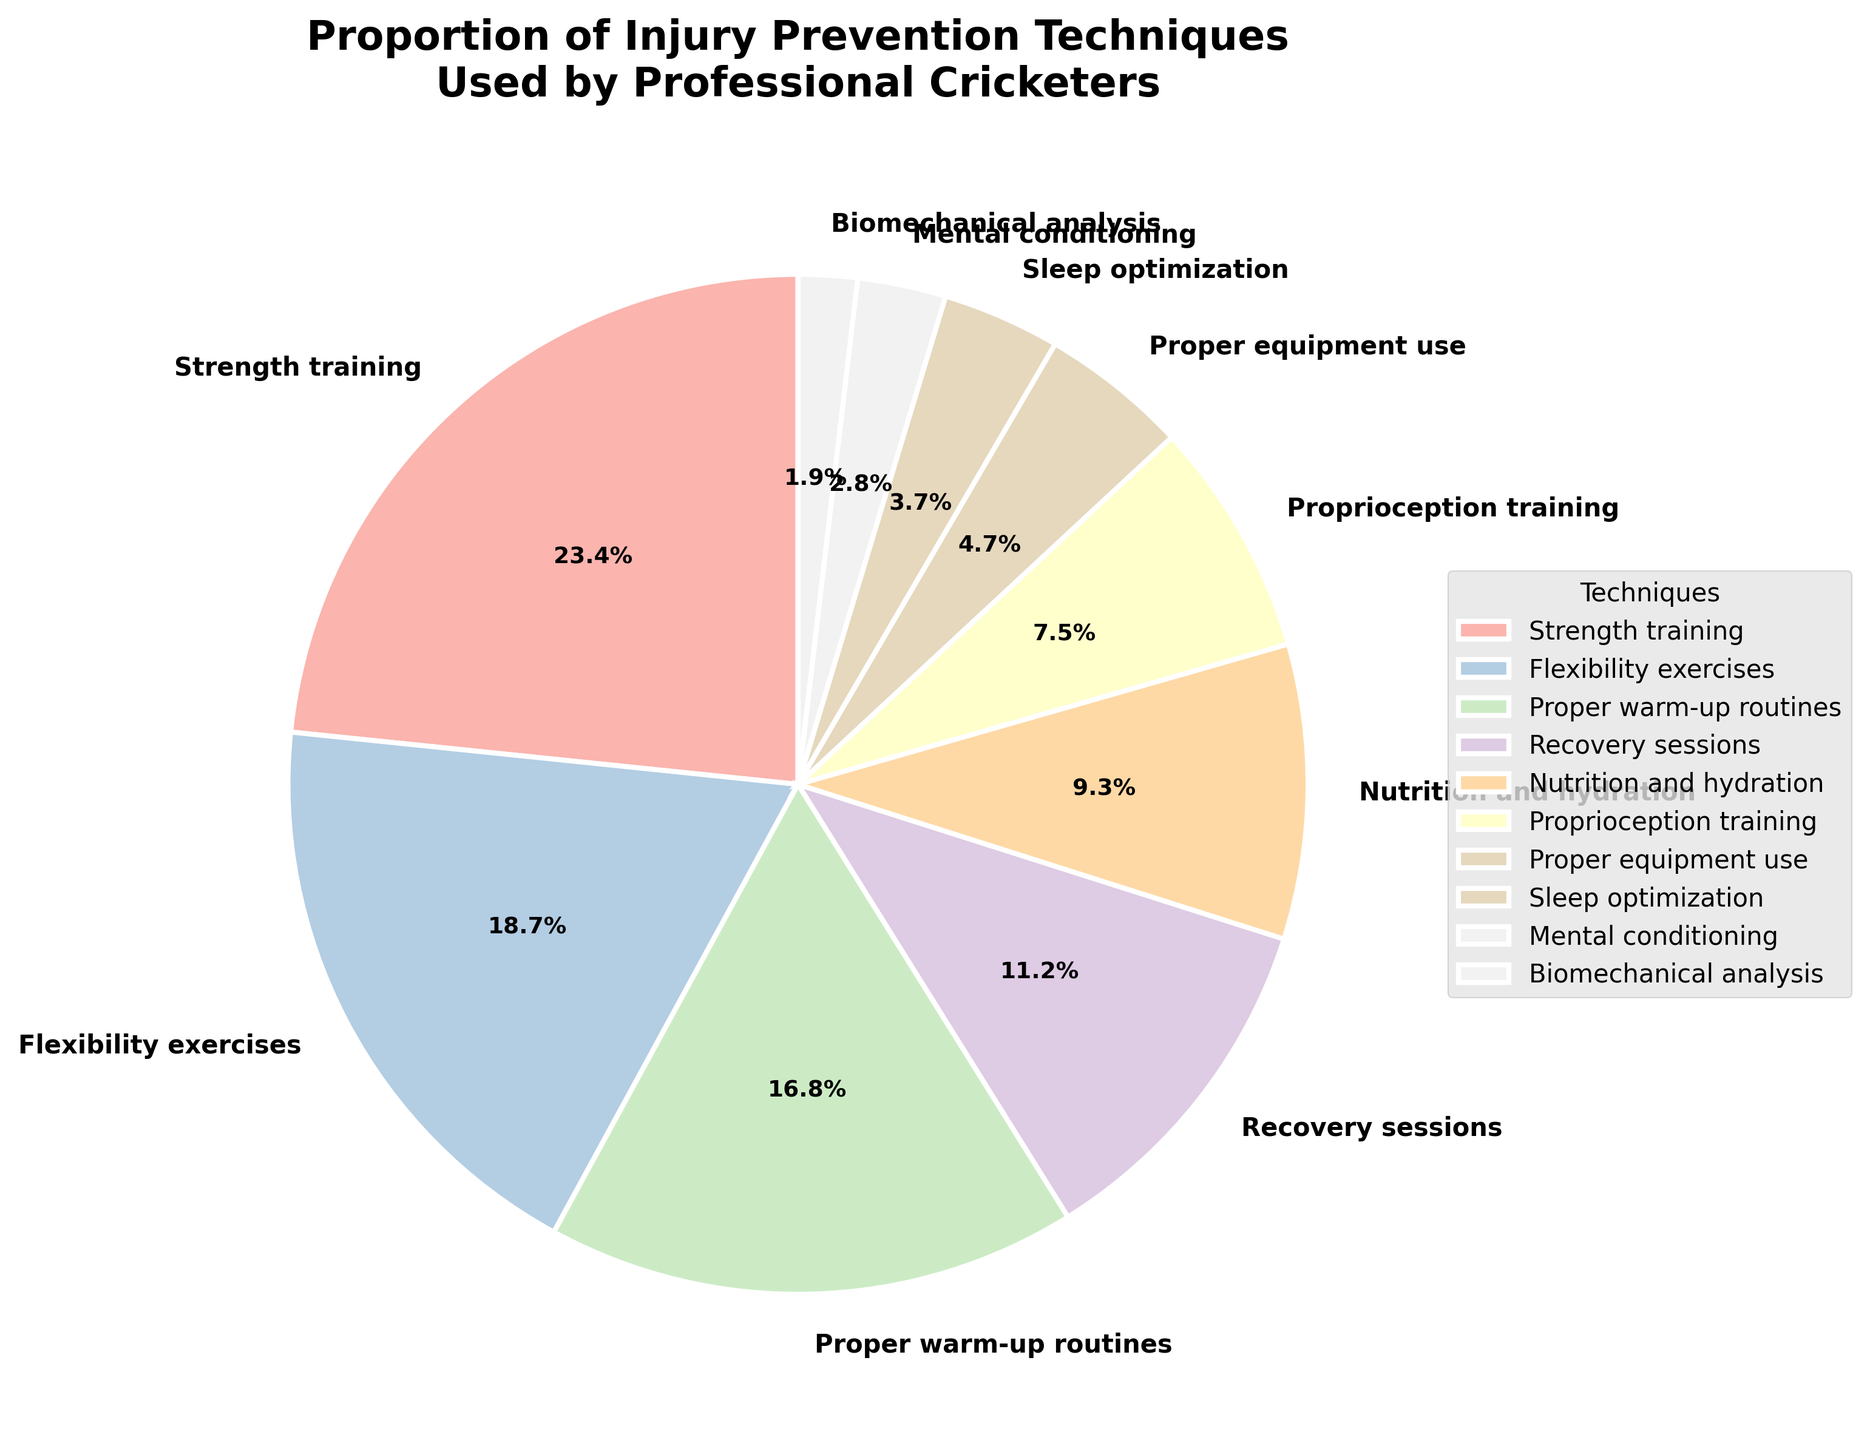Which technique is used the most? By looking at the pie chart, the largest section represents "Strength training" at 25%, which is the highest value among all techniques.
Answer: Strength training Which technique is used the least? The smallest section of the pie chart represents "Biomechanical analysis" at 2%, which is the lowest value among all techniques.
Answer: Biomechanical analysis How much more is the percentage of Strength training compared to Proper equipment use? The percentage of Strength training is 25% and Proper equipment use is 5%. The difference is 25 - 5.
Answer: 20% Which techniques account for over 15% each? By examining the pie chart, "Strength training" (25%), "Flexibility exercises" (20%), and "Proper warm-up routines" (18%) each have a percentage over 15%.
Answer: Strength training, Flexibility exercises, Proper warm-up routines What is the combined percentage of Nutrition and hydration and Sleep optimization? The percentage of Nutrition and hydration is 10% and Sleep optimization is 4%. The combined percentage is 10 + 4.
Answer: 14% Is the percentage of Recovery sessions greater than the percentage of Proprioception training and Biomechanical analysis combined? The percentage of Recovery sessions is 12%, and the combined percentage of Proprioception training (8%) and Biomechanical analysis (2%) is 8 + 2 = 10%. Since 12% is greater than 10%, the statement is true.
Answer: Yes Which two techniques together make up nearly one-third of the total percentage? One-third of 100% is approximately 33.3%. The combination of "Strength training" (25%) and "Flexibility exercises" (20%) equals 25 + 20 = 45%. The combination of "Strength training" (25%) and "Proper warm-up routines" (18%) equals 25 + 18 = 43%, which is closer to one-third.
Answer: Strength training and Proper warm-up routines How much more is the sum of Flexibility exercises and Proprioception training compared to Sleep optimization? Flexibility exercises is 20%, and Proprioception training is 8%, so their sum is 20 + 8 = 28%. Sleep optimization is 4%. The difference is 28 - 4.
Answer: 24% 